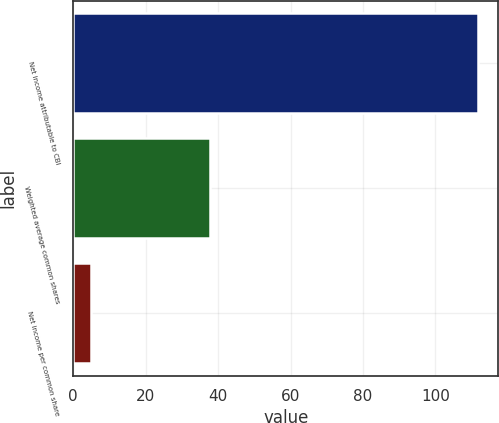Convert chart. <chart><loc_0><loc_0><loc_500><loc_500><bar_chart><fcel>Net income attributable to CBI<fcel>Weighted average common shares<fcel>Net income per common share<nl><fcel>111.8<fcel>37.82<fcel>4.79<nl></chart> 